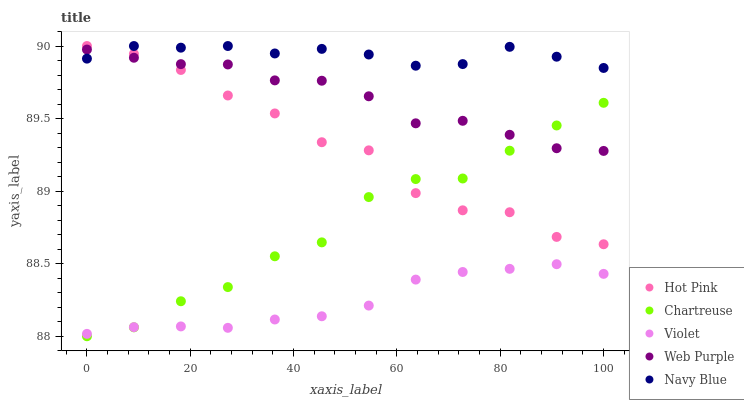Does Violet have the minimum area under the curve?
Answer yes or no. Yes. Does Navy Blue have the maximum area under the curve?
Answer yes or no. Yes. Does Chartreuse have the minimum area under the curve?
Answer yes or no. No. Does Chartreuse have the maximum area under the curve?
Answer yes or no. No. Is Violet the smoothest?
Answer yes or no. Yes. Is Hot Pink the roughest?
Answer yes or no. Yes. Is Chartreuse the smoothest?
Answer yes or no. No. Is Chartreuse the roughest?
Answer yes or no. No. Does Chartreuse have the lowest value?
Answer yes or no. Yes. Does Hot Pink have the lowest value?
Answer yes or no. No. Does Hot Pink have the highest value?
Answer yes or no. Yes. Does Chartreuse have the highest value?
Answer yes or no. No. Is Chartreuse less than Navy Blue?
Answer yes or no. Yes. Is Navy Blue greater than Chartreuse?
Answer yes or no. Yes. Does Chartreuse intersect Violet?
Answer yes or no. Yes. Is Chartreuse less than Violet?
Answer yes or no. No. Is Chartreuse greater than Violet?
Answer yes or no. No. Does Chartreuse intersect Navy Blue?
Answer yes or no. No. 